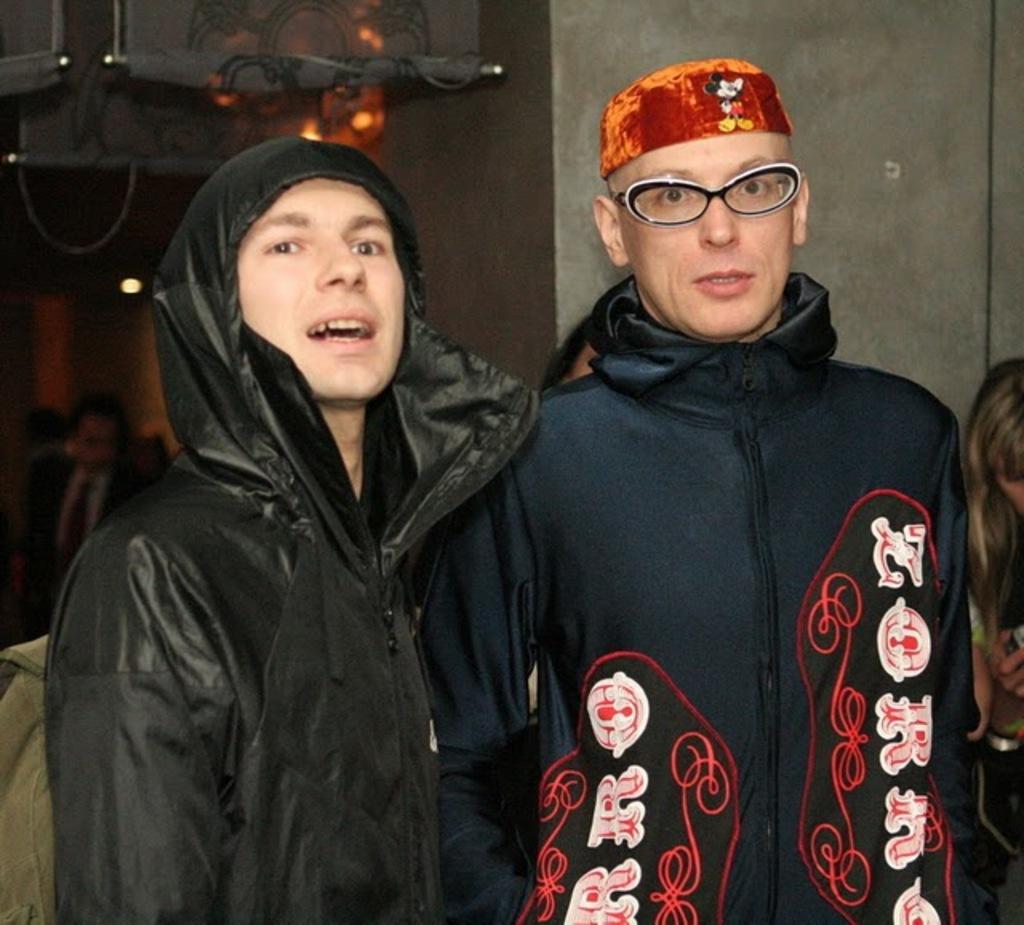Could you give a brief overview of what you see in this image? In the center of the image we can see two persons are standing and wearing coat, cap and a man is wearing spectacles. On the right side of the image we can see a person. On the left side of the image we can see a man is sitting. In the background of the image we can see the wall, lights and an object. 